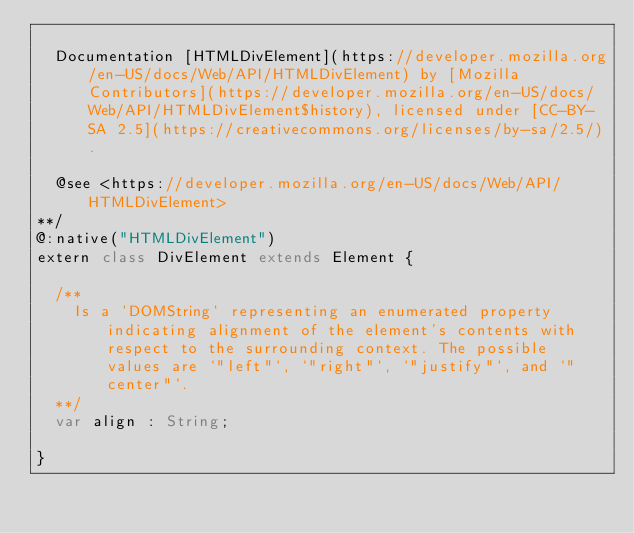Convert code to text. <code><loc_0><loc_0><loc_500><loc_500><_Haxe_>
	Documentation [HTMLDivElement](https://developer.mozilla.org/en-US/docs/Web/API/HTMLDivElement) by [Mozilla Contributors](https://developer.mozilla.org/en-US/docs/Web/API/HTMLDivElement$history), licensed under [CC-BY-SA 2.5](https://creativecommons.org/licenses/by-sa/2.5/).

	@see <https://developer.mozilla.org/en-US/docs/Web/API/HTMLDivElement>
**/
@:native("HTMLDivElement")
extern class DivElement extends Element {
	
	/**
		Is a `DOMString` representing an enumerated property indicating alignment of the element's contents with respect to the surrounding context. The possible values are `"left"`, `"right"`, `"justify"`, and `"center"`.
	**/
	var align : String;
	
}</code> 